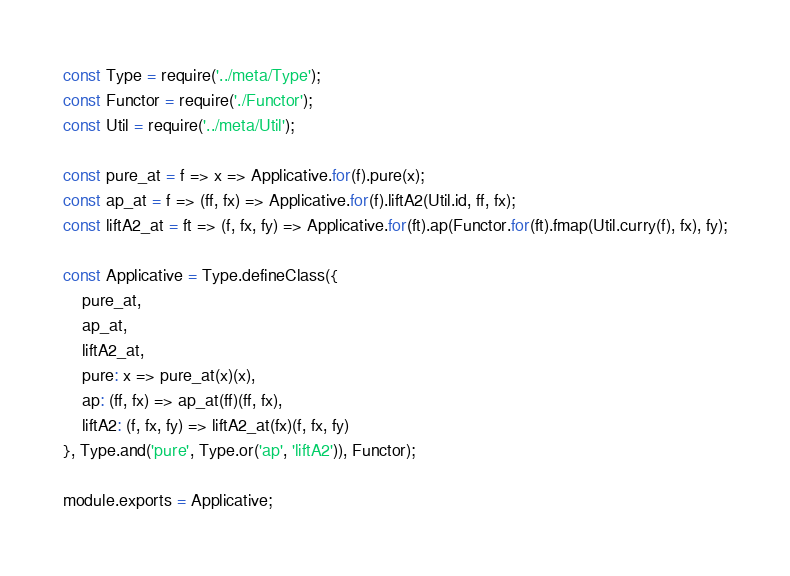<code> <loc_0><loc_0><loc_500><loc_500><_JavaScript_>const Type = require('../meta/Type');
const Functor = require('./Functor');
const Util = require('../meta/Util');

const pure_at = f => x => Applicative.for(f).pure(x);
const ap_at = f => (ff, fx) => Applicative.for(f).liftA2(Util.id, ff, fx);
const liftA2_at = ft => (f, fx, fy) => Applicative.for(ft).ap(Functor.for(ft).fmap(Util.curry(f), fx), fy);

const Applicative = Type.defineClass({
    pure_at,
    ap_at,
    liftA2_at,
    pure: x => pure_at(x)(x),
    ap: (ff, fx) => ap_at(ff)(ff, fx),
    liftA2: (f, fx, fy) => liftA2_at(fx)(f, fx, fy)
}, Type.and('pure', Type.or('ap', 'liftA2')), Functor);

module.exports = Applicative;
</code> 